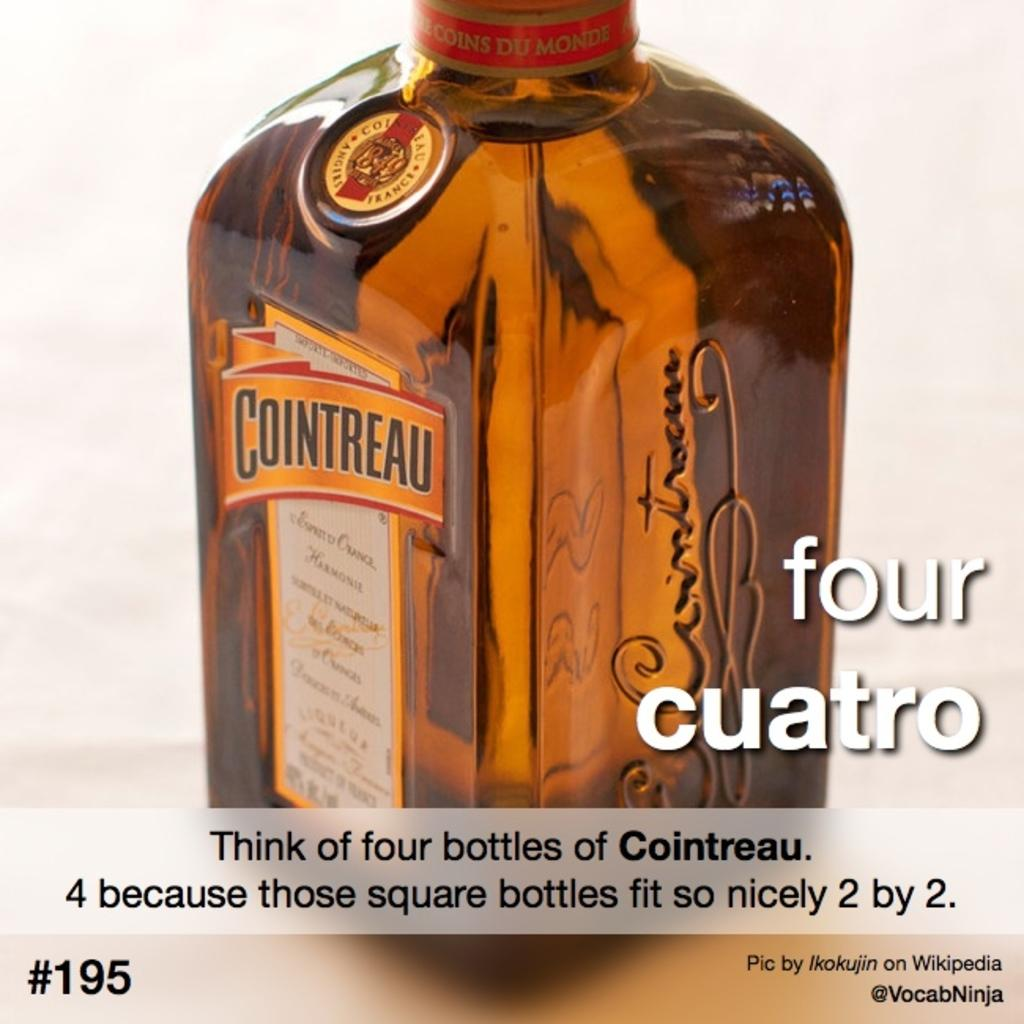<image>
Create a compact narrative representing the image presented. A bottle of alcohol called Cointreau with a signature on the side 